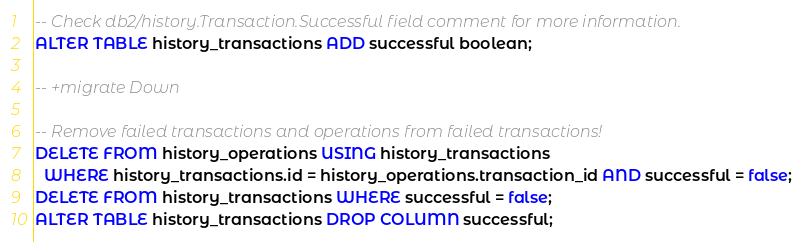Convert code to text. <code><loc_0><loc_0><loc_500><loc_500><_SQL_>-- Check db2/history.Transaction.Successful field comment for more information.
ALTER TABLE history_transactions ADD successful boolean;

-- +migrate Down

-- Remove failed transactions and operations from failed transactions!
DELETE FROM history_operations USING history_transactions
  WHERE history_transactions.id = history_operations.transaction_id AND successful = false;
DELETE FROM history_transactions WHERE successful = false;
ALTER TABLE history_transactions DROP COLUMN successful;
</code> 